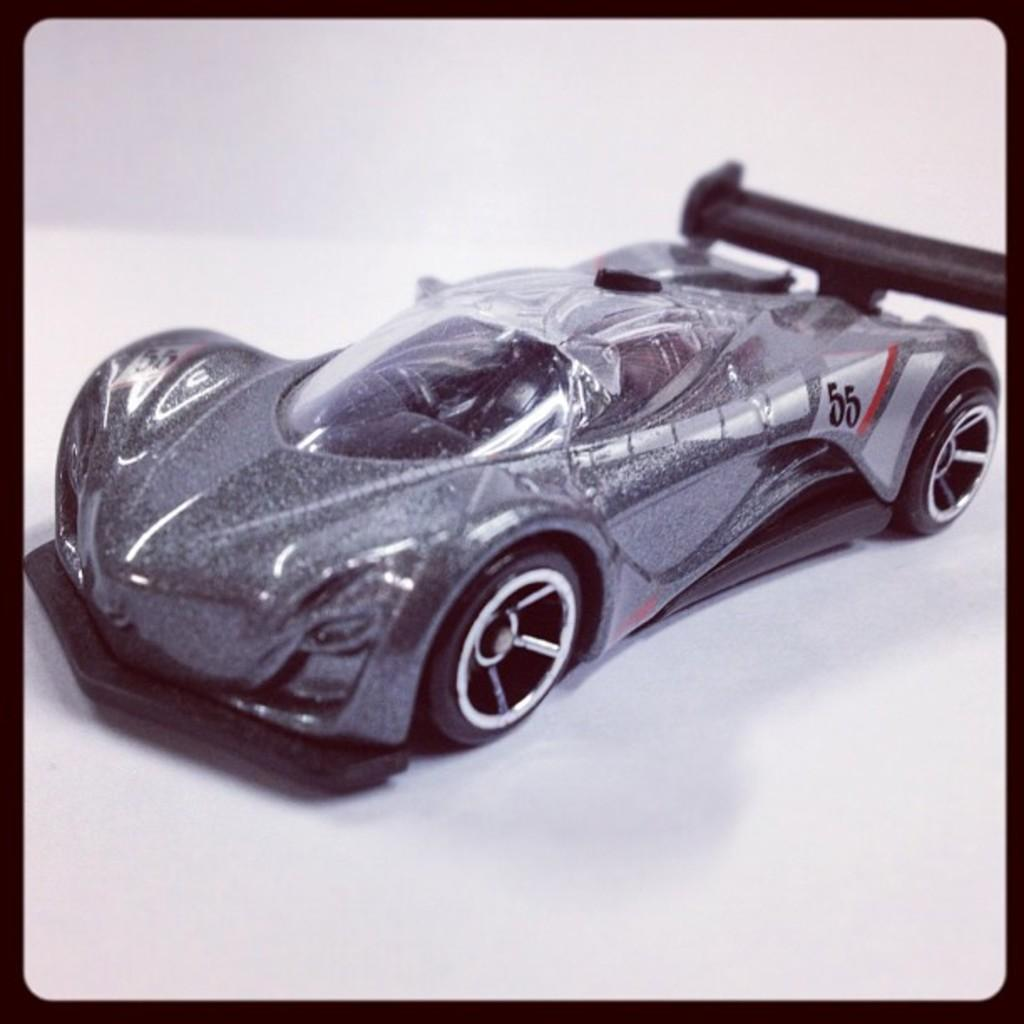Provide a one-sentence caption for the provided image. a car with the numbers 55 on the side. 